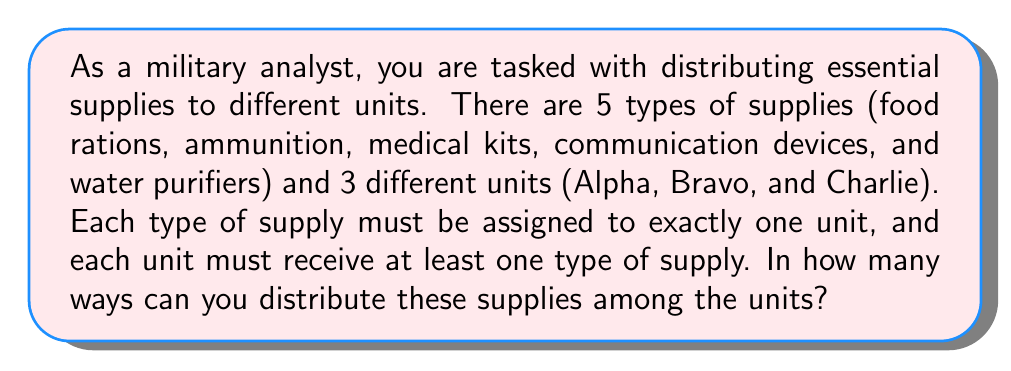Provide a solution to this math problem. To solve this problem, we can use the concept of stirling numbers of the second kind and the inclusion-exclusion principle.

Let's approach this step-by-step:

1) First, let's consider the total number of ways to distribute 5 supplies among 3 units without any restrictions. This would be $3^5 = 243$, as each supply has 3 choices.

2) However, we need to exclude cases where one or more units receive no supplies. Let's use the inclusion-exclusion principle:

   Let $A_i$ be the set of distributions where unit $i$ receives no supplies.

3) We need to calculate:
   $$ |A_1 \cup A_2 \cup A_3| = |A_1| + |A_2| + |A_3| - |A_1 \cap A_2| - |A_1 \cap A_3| - |A_2 \cap A_3| + |A_1 \cap A_2 \cap A_3| $$

4) $|A_i| = 2^5 = 32$ (distributing 5 supplies among the other 2 units)
   $|A_i \cap A_j| = 1^5 = 1$ (all supplies go to the remaining unit)
   $|A_1 \cap A_2 \cap A_3| = 0$ (impossible as all units must receive at least one supply)

5) Substituting these values:
   $$ |A_1 \cup A_2 \cup A_3| = 32 + 32 + 32 - 1 - 1 - 1 + 0 = 93 $$

6) Therefore, the number of valid distributions is:
   $$ 3^5 - 93 = 243 - 93 = 150 $$

This is equivalent to the Stirling number of the second kind $\stirling{5}{3}$, which represents the number of ways to partition a set of 5 elements into 3 non-empty subsets.
Answer: 150 